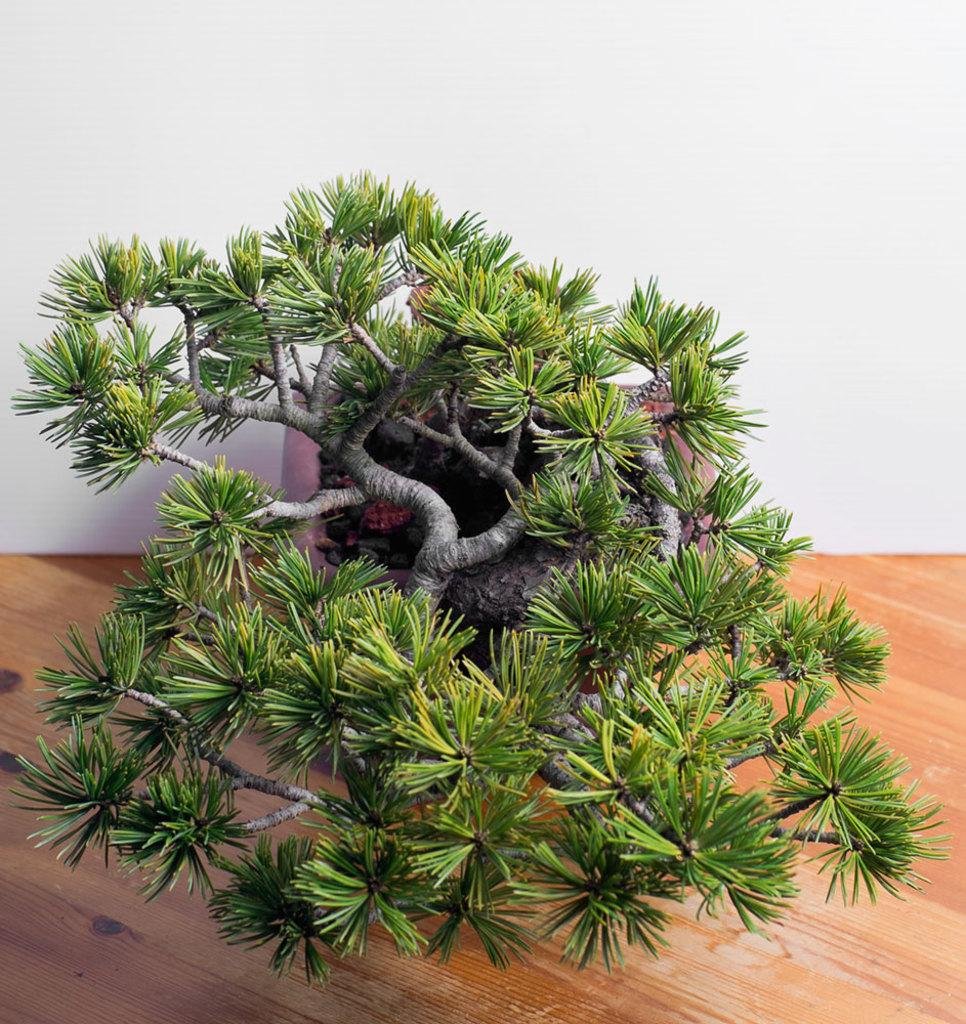What type of plant is in the image? There is a bonsai tree in the image. What is the bonsai tree placed on? The bonsai tree is on a wooden surface. What can be seen behind the bonsai tree? There is a white wall in the background of the image. How does the bonsai tree affect the nerves in the image? The bonsai tree does not affect any nerves in the image, as it is an inanimate object. 